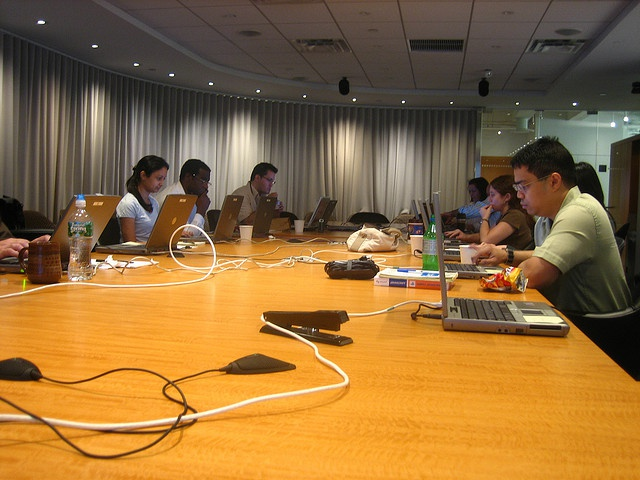Describe the objects in this image and their specific colors. I can see people in black, gray, maroon, and tan tones, laptop in black, gray, and maroon tones, people in black, maroon, and gray tones, people in black, maroon, and brown tones, and laptop in black, maroon, gray, and brown tones in this image. 